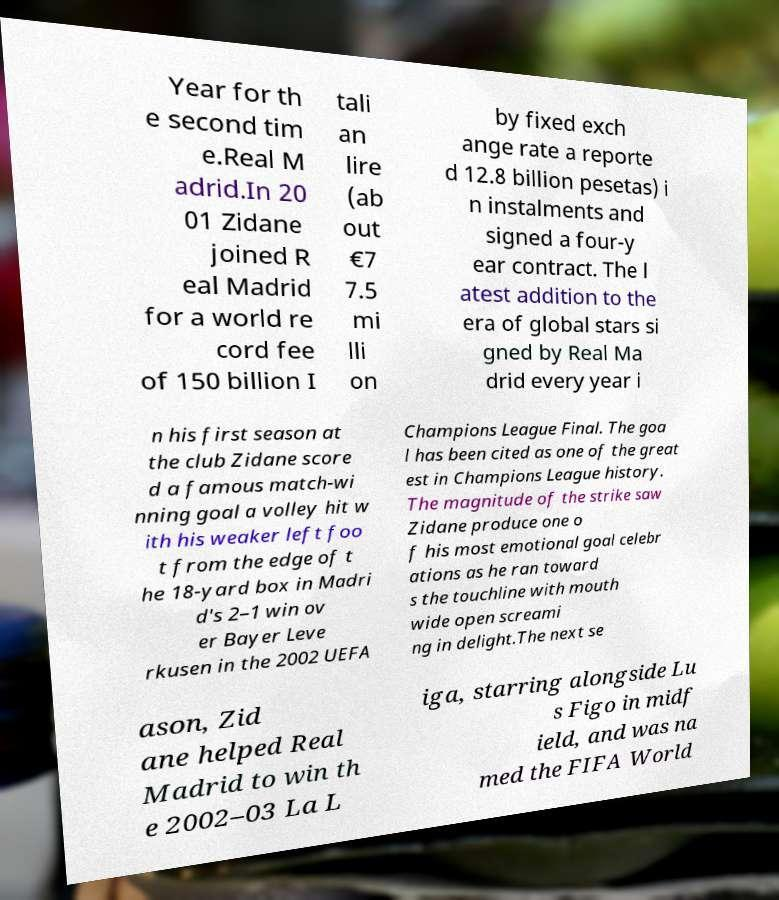Please identify and transcribe the text found in this image. Year for th e second tim e.Real M adrid.In 20 01 Zidane joined R eal Madrid for a world re cord fee of 150 billion I tali an lire (ab out €7 7.5 mi lli on by fixed exch ange rate a reporte d 12.8 billion pesetas) i n instalments and signed a four-y ear contract. The l atest addition to the era of global stars si gned by Real Ma drid every year i n his first season at the club Zidane score d a famous match-wi nning goal a volley hit w ith his weaker left foo t from the edge of t he 18-yard box in Madri d's 2–1 win ov er Bayer Leve rkusen in the 2002 UEFA Champions League Final. The goa l has been cited as one of the great est in Champions League history. The magnitude of the strike saw Zidane produce one o f his most emotional goal celebr ations as he ran toward s the touchline with mouth wide open screami ng in delight.The next se ason, Zid ane helped Real Madrid to win th e 2002–03 La L iga, starring alongside Lu s Figo in midf ield, and was na med the FIFA World 